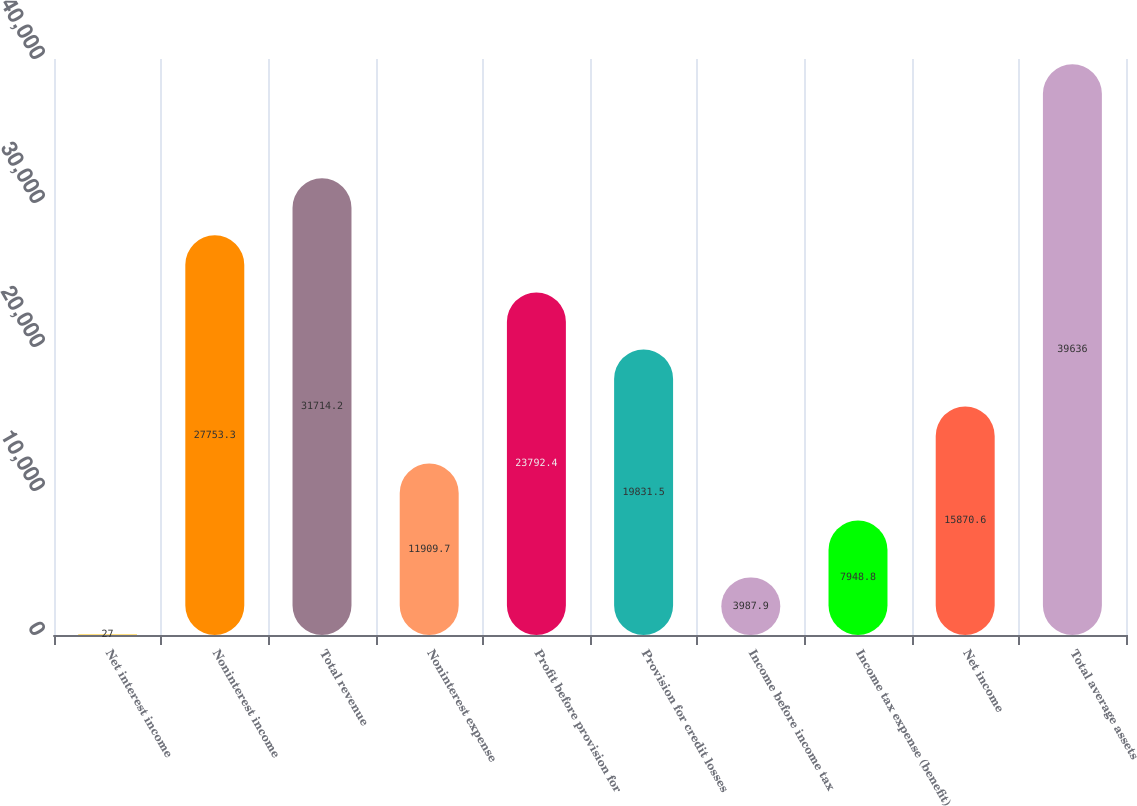Convert chart to OTSL. <chart><loc_0><loc_0><loc_500><loc_500><bar_chart><fcel>Net interest income<fcel>Noninterest income<fcel>Total revenue<fcel>Noninterest expense<fcel>Profit before provision for<fcel>Provision for credit losses<fcel>Income before income tax<fcel>Income tax expense (benefit)<fcel>Net income<fcel>Total average assets<nl><fcel>27<fcel>27753.3<fcel>31714.2<fcel>11909.7<fcel>23792.4<fcel>19831.5<fcel>3987.9<fcel>7948.8<fcel>15870.6<fcel>39636<nl></chart> 